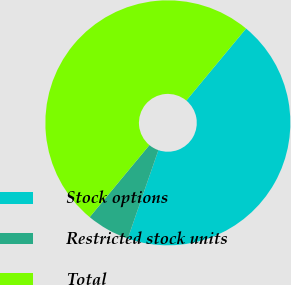Convert chart. <chart><loc_0><loc_0><loc_500><loc_500><pie_chart><fcel>Stock options<fcel>Restricted stock units<fcel>Total<nl><fcel>44.29%<fcel>5.71%<fcel>50.0%<nl></chart> 